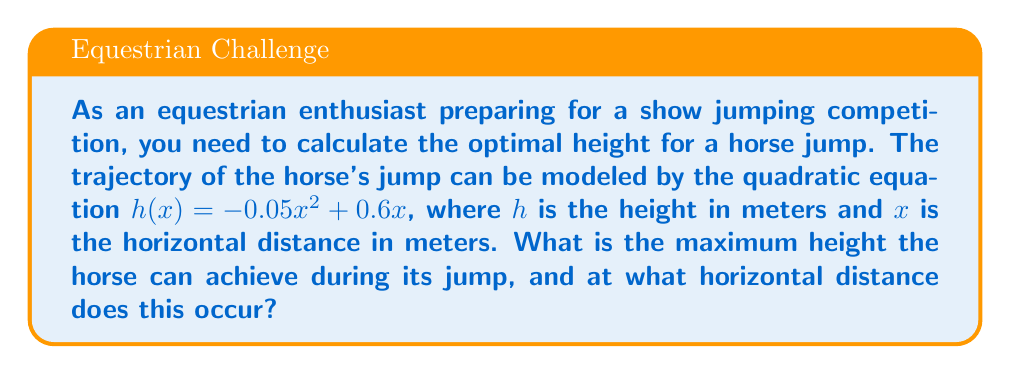Show me your answer to this math problem. To solve this problem, we need to follow these steps:

1) The quadratic equation given is $h(x) = -0.05x^2 + 0.6x$

2) To find the maximum height, we need to find the vertex of this parabola. For a quadratic equation in the form $ax^2 + bx + c$, the x-coordinate of the vertex is given by $x = -\frac{b}{2a}$

3) In our equation, $a = -0.05$ and $b = 0.6$. Let's substitute these values:

   $x = -\frac{0.6}{2(-0.05)} = -\frac{0.6}{-0.1} = 6$

4) This means the maximum height occurs when $x = 6$ meters.

5) To find the maximum height, we substitute $x = 6$ into our original equation:

   $h(6) = -0.05(6)^2 + 0.6(6)$
   $    = -0.05(36) + 3.6$
   $    = -1.8 + 3.6$
   $    = 1.8$

Therefore, the maximum height is 1.8 meters.
Answer: The horse can achieve a maximum height of 1.8 meters at a horizontal distance of 6 meters from the starting point. 